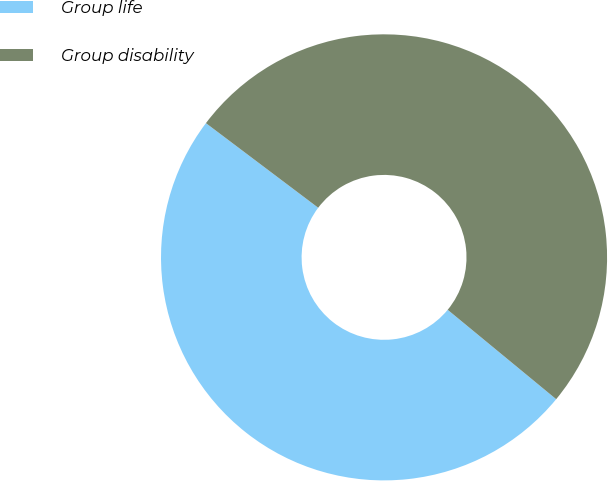Convert chart. <chart><loc_0><loc_0><loc_500><loc_500><pie_chart><fcel>Group life<fcel>Group disability<nl><fcel>49.31%<fcel>50.69%<nl></chart> 